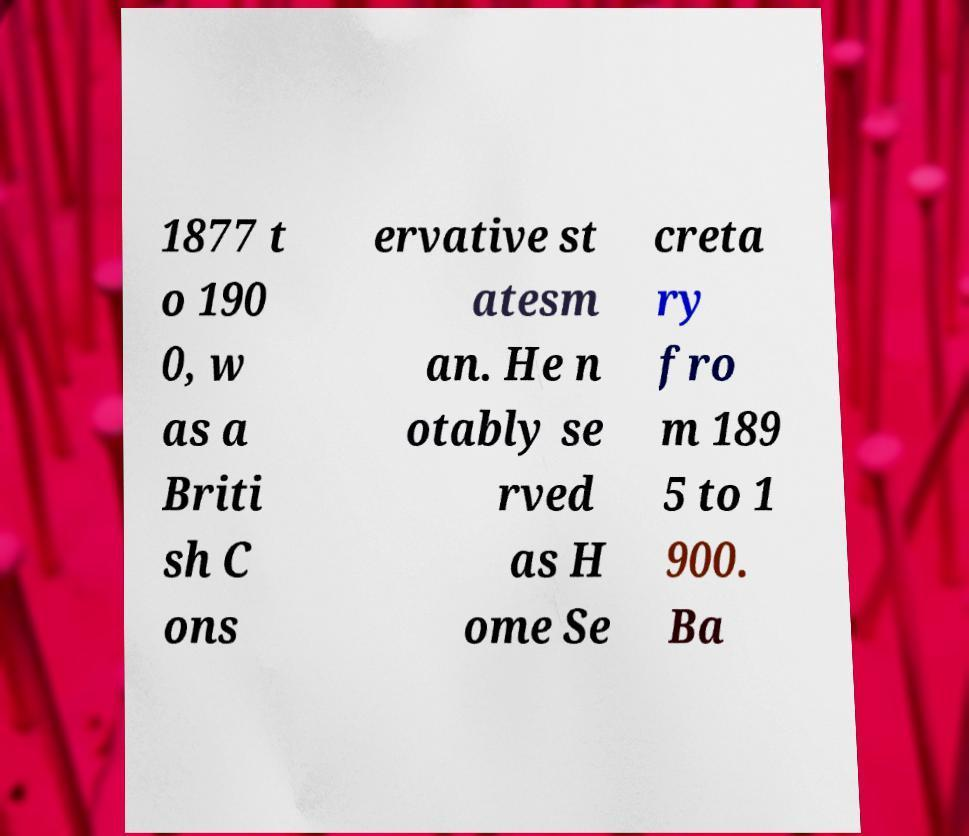Can you read and provide the text displayed in the image?This photo seems to have some interesting text. Can you extract and type it out for me? 1877 t o 190 0, w as a Briti sh C ons ervative st atesm an. He n otably se rved as H ome Se creta ry fro m 189 5 to 1 900. Ba 